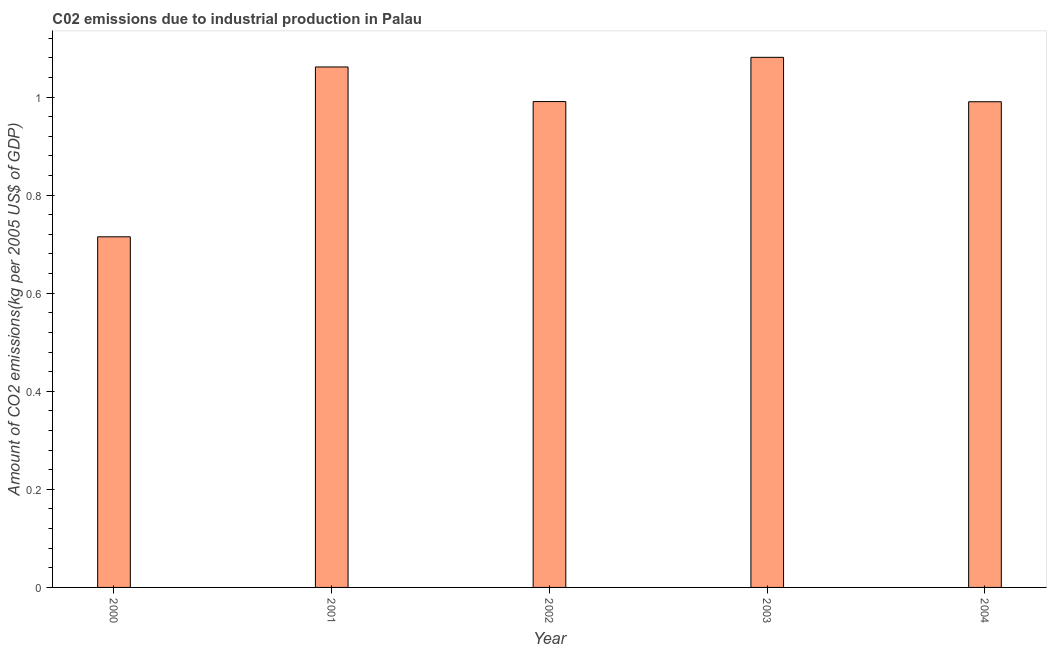Does the graph contain grids?
Provide a succinct answer. No. What is the title of the graph?
Your answer should be compact. C02 emissions due to industrial production in Palau. What is the label or title of the Y-axis?
Make the answer very short. Amount of CO2 emissions(kg per 2005 US$ of GDP). What is the amount of co2 emissions in 2000?
Make the answer very short. 0.71. Across all years, what is the maximum amount of co2 emissions?
Offer a very short reply. 1.08. Across all years, what is the minimum amount of co2 emissions?
Ensure brevity in your answer.  0.71. In which year was the amount of co2 emissions maximum?
Keep it short and to the point. 2003. What is the sum of the amount of co2 emissions?
Give a very brief answer. 4.84. What is the difference between the amount of co2 emissions in 2002 and 2003?
Offer a terse response. -0.09. What is the median amount of co2 emissions?
Keep it short and to the point. 0.99. In how many years, is the amount of co2 emissions greater than 0.08 kg per 2005 US$ of GDP?
Offer a terse response. 5. What is the ratio of the amount of co2 emissions in 2002 to that in 2004?
Offer a terse response. 1. Is the amount of co2 emissions in 2000 less than that in 2001?
Your response must be concise. Yes. What is the difference between the highest and the lowest amount of co2 emissions?
Your answer should be very brief. 0.37. How many years are there in the graph?
Ensure brevity in your answer.  5. What is the Amount of CO2 emissions(kg per 2005 US$ of GDP) of 2000?
Give a very brief answer. 0.71. What is the Amount of CO2 emissions(kg per 2005 US$ of GDP) of 2001?
Provide a short and direct response. 1.06. What is the Amount of CO2 emissions(kg per 2005 US$ of GDP) of 2002?
Provide a short and direct response. 0.99. What is the Amount of CO2 emissions(kg per 2005 US$ of GDP) of 2003?
Offer a very short reply. 1.08. What is the Amount of CO2 emissions(kg per 2005 US$ of GDP) of 2004?
Make the answer very short. 0.99. What is the difference between the Amount of CO2 emissions(kg per 2005 US$ of GDP) in 2000 and 2001?
Your response must be concise. -0.35. What is the difference between the Amount of CO2 emissions(kg per 2005 US$ of GDP) in 2000 and 2002?
Provide a short and direct response. -0.28. What is the difference between the Amount of CO2 emissions(kg per 2005 US$ of GDP) in 2000 and 2003?
Offer a terse response. -0.37. What is the difference between the Amount of CO2 emissions(kg per 2005 US$ of GDP) in 2000 and 2004?
Offer a very short reply. -0.28. What is the difference between the Amount of CO2 emissions(kg per 2005 US$ of GDP) in 2001 and 2002?
Your answer should be very brief. 0.07. What is the difference between the Amount of CO2 emissions(kg per 2005 US$ of GDP) in 2001 and 2003?
Your response must be concise. -0.02. What is the difference between the Amount of CO2 emissions(kg per 2005 US$ of GDP) in 2001 and 2004?
Ensure brevity in your answer.  0.07. What is the difference between the Amount of CO2 emissions(kg per 2005 US$ of GDP) in 2002 and 2003?
Offer a very short reply. -0.09. What is the difference between the Amount of CO2 emissions(kg per 2005 US$ of GDP) in 2002 and 2004?
Your answer should be very brief. 0. What is the difference between the Amount of CO2 emissions(kg per 2005 US$ of GDP) in 2003 and 2004?
Provide a short and direct response. 0.09. What is the ratio of the Amount of CO2 emissions(kg per 2005 US$ of GDP) in 2000 to that in 2001?
Your answer should be very brief. 0.67. What is the ratio of the Amount of CO2 emissions(kg per 2005 US$ of GDP) in 2000 to that in 2002?
Your answer should be very brief. 0.72. What is the ratio of the Amount of CO2 emissions(kg per 2005 US$ of GDP) in 2000 to that in 2003?
Your answer should be very brief. 0.66. What is the ratio of the Amount of CO2 emissions(kg per 2005 US$ of GDP) in 2000 to that in 2004?
Ensure brevity in your answer.  0.72. What is the ratio of the Amount of CO2 emissions(kg per 2005 US$ of GDP) in 2001 to that in 2002?
Your response must be concise. 1.07. What is the ratio of the Amount of CO2 emissions(kg per 2005 US$ of GDP) in 2001 to that in 2003?
Make the answer very short. 0.98. What is the ratio of the Amount of CO2 emissions(kg per 2005 US$ of GDP) in 2001 to that in 2004?
Your answer should be compact. 1.07. What is the ratio of the Amount of CO2 emissions(kg per 2005 US$ of GDP) in 2002 to that in 2003?
Give a very brief answer. 0.92. What is the ratio of the Amount of CO2 emissions(kg per 2005 US$ of GDP) in 2002 to that in 2004?
Provide a succinct answer. 1. What is the ratio of the Amount of CO2 emissions(kg per 2005 US$ of GDP) in 2003 to that in 2004?
Your response must be concise. 1.09. 